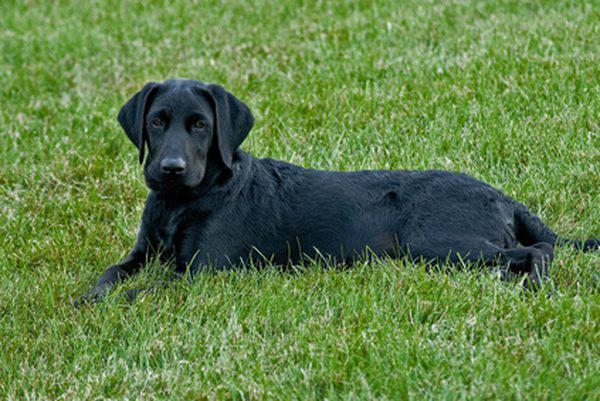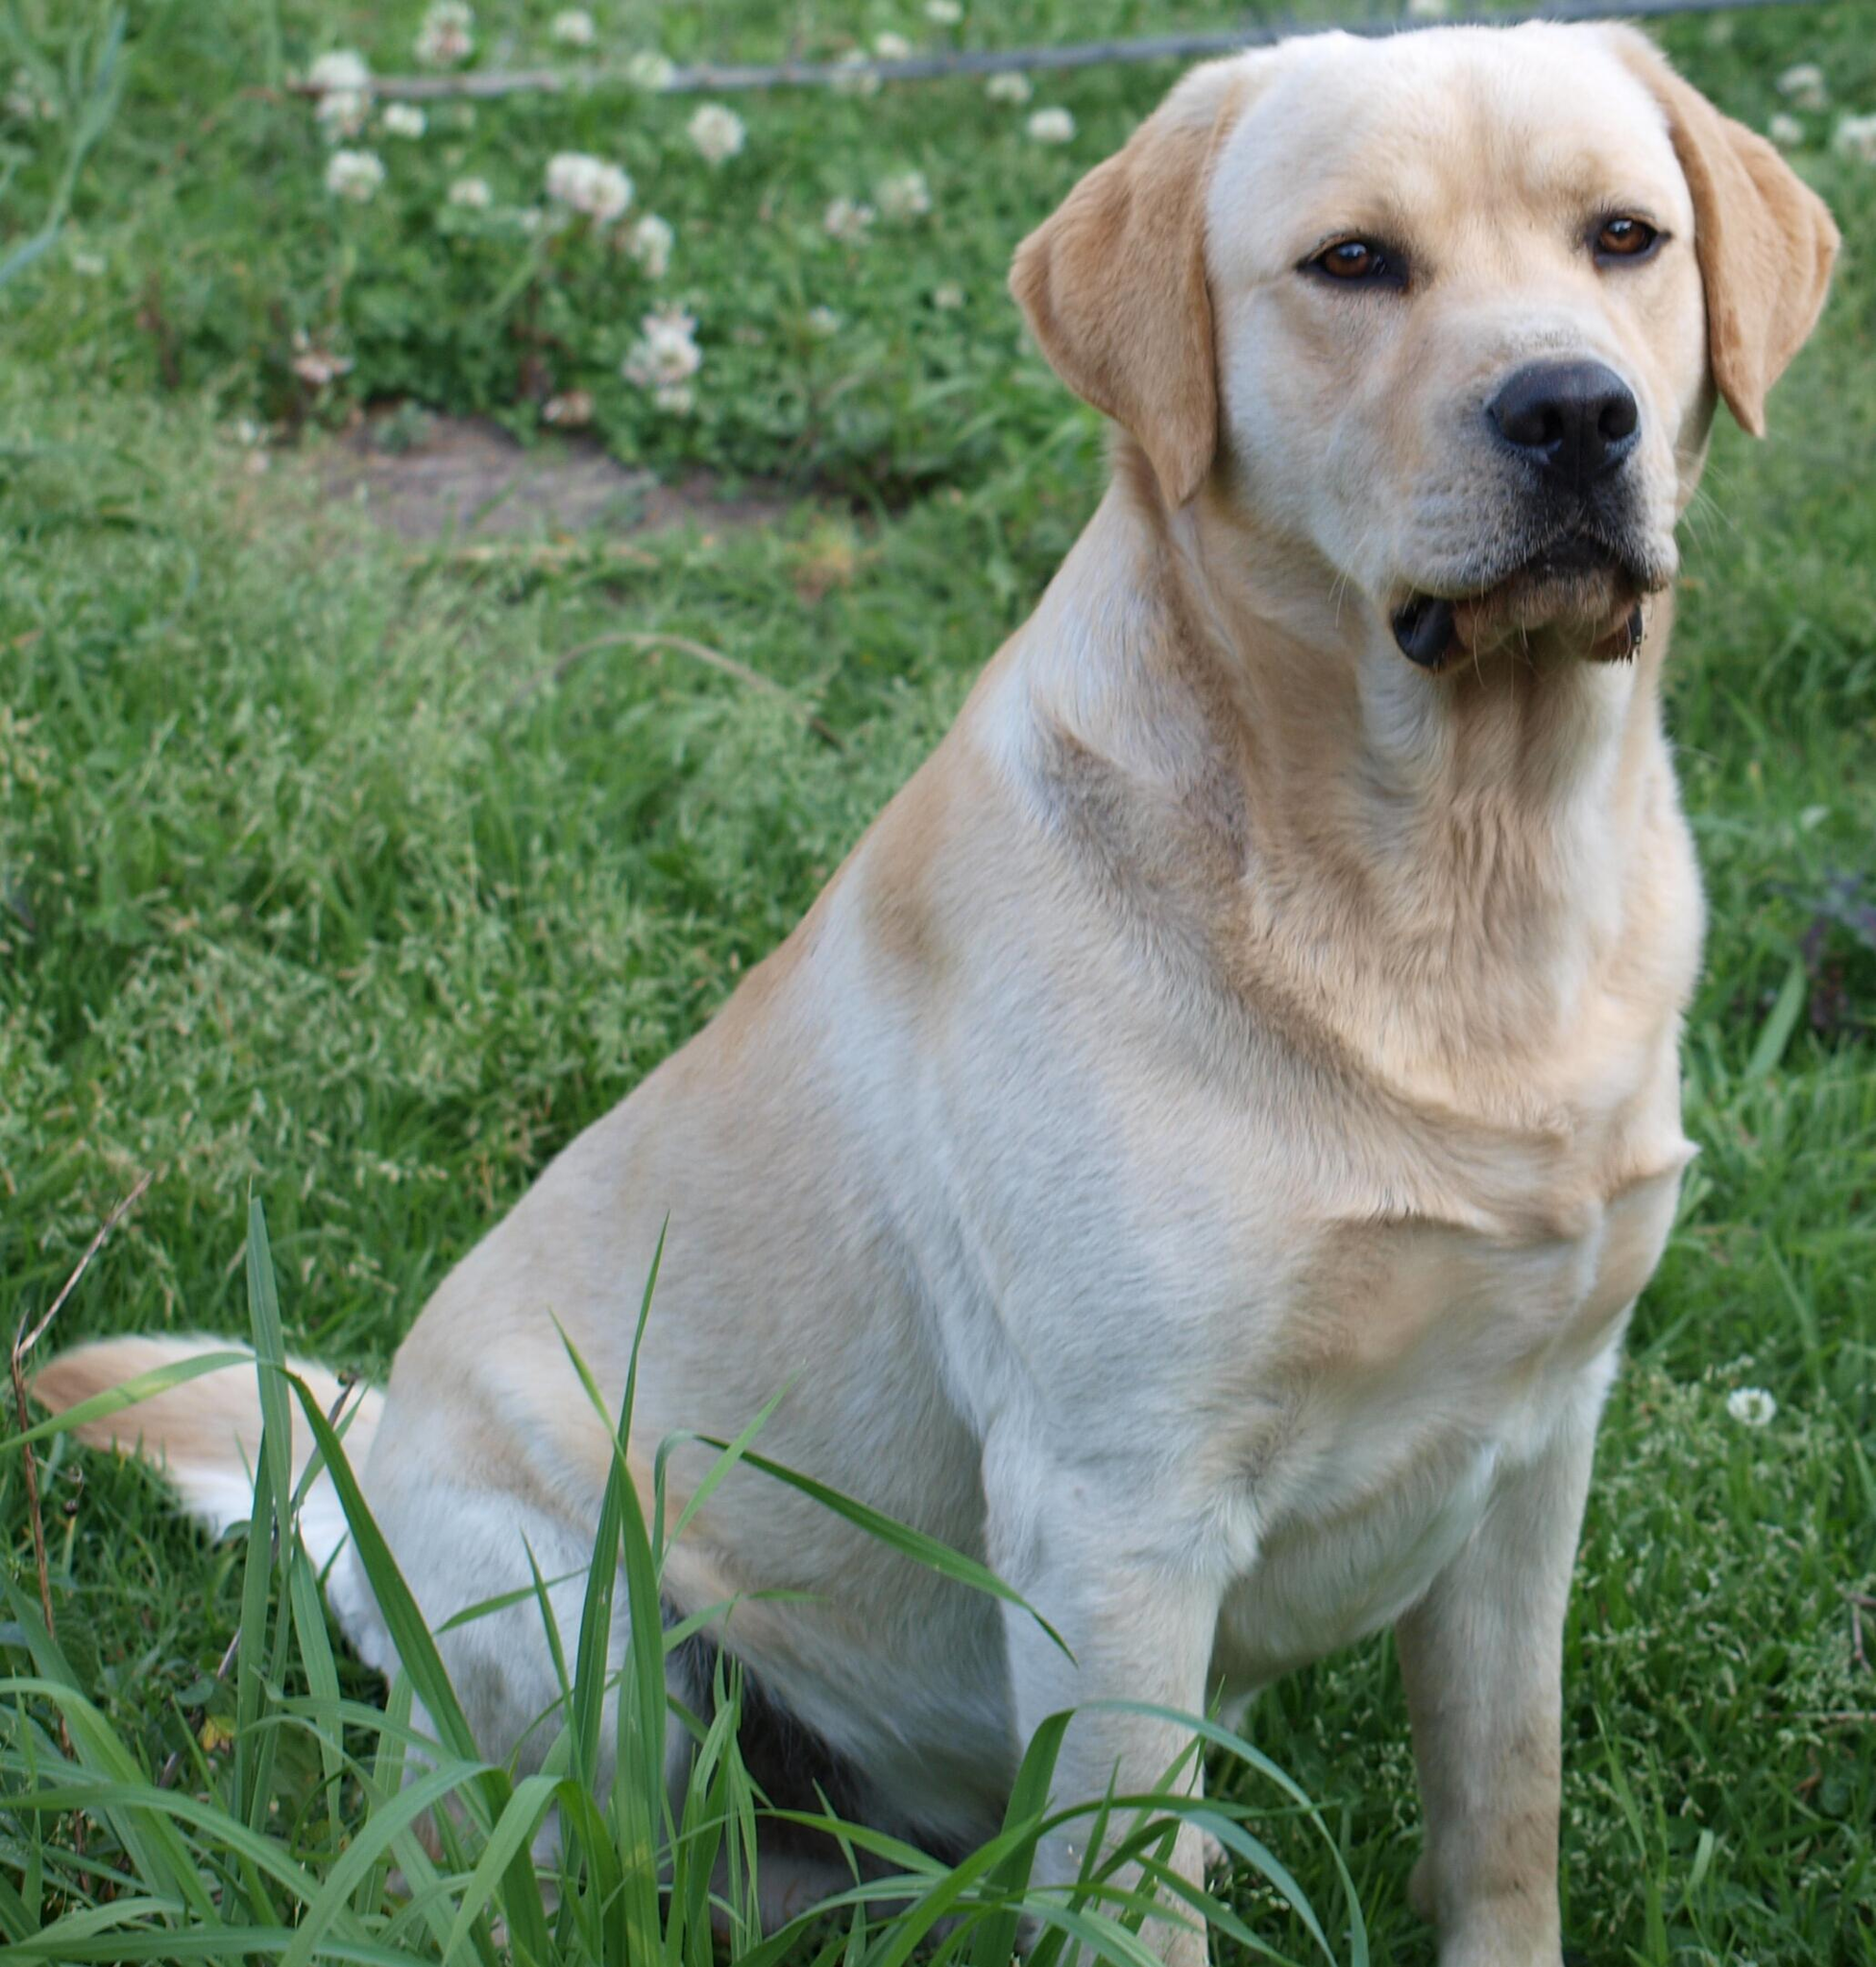The first image is the image on the left, the second image is the image on the right. For the images displayed, is the sentence "At least four dogs in a grassy area have their mouths open and their tongues showing." factually correct? Answer yes or no. No. The first image is the image on the left, the second image is the image on the right. Considering the images on both sides, is "There are more dogs in the left image than in the right." valid? Answer yes or no. No. 